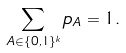<formula> <loc_0><loc_0><loc_500><loc_500>\sum _ { A \in \{ 0 , 1 \} ^ { k } } p _ { A } = 1 .</formula> 